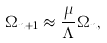Convert formula to latex. <formula><loc_0><loc_0><loc_500><loc_500>\Omega _ { n + 1 } \approx \frac { \mu } { \Lambda } \Omega _ { n } ,</formula> 